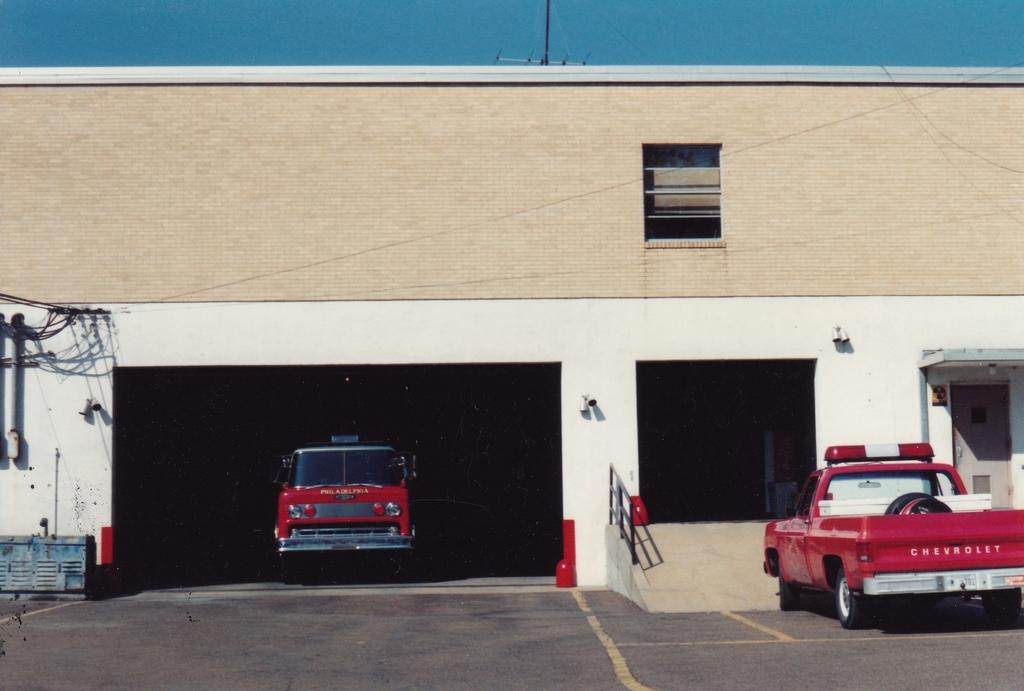What is the main subject in the center of the image? There is a building in the center of the image. What else can be seen at the bottom of the image? Vehicles are visible on the road at the bottom of the image. What is visible at the top of the image? The sky is visible at the top of the image. How many geese are flying in space in the image? There are no geese or space present in the image; it features a building, vehicles, and the sky. What type of calculator can be seen on the roof of the building? There is no calculator visible on the roof of the building in the image. 